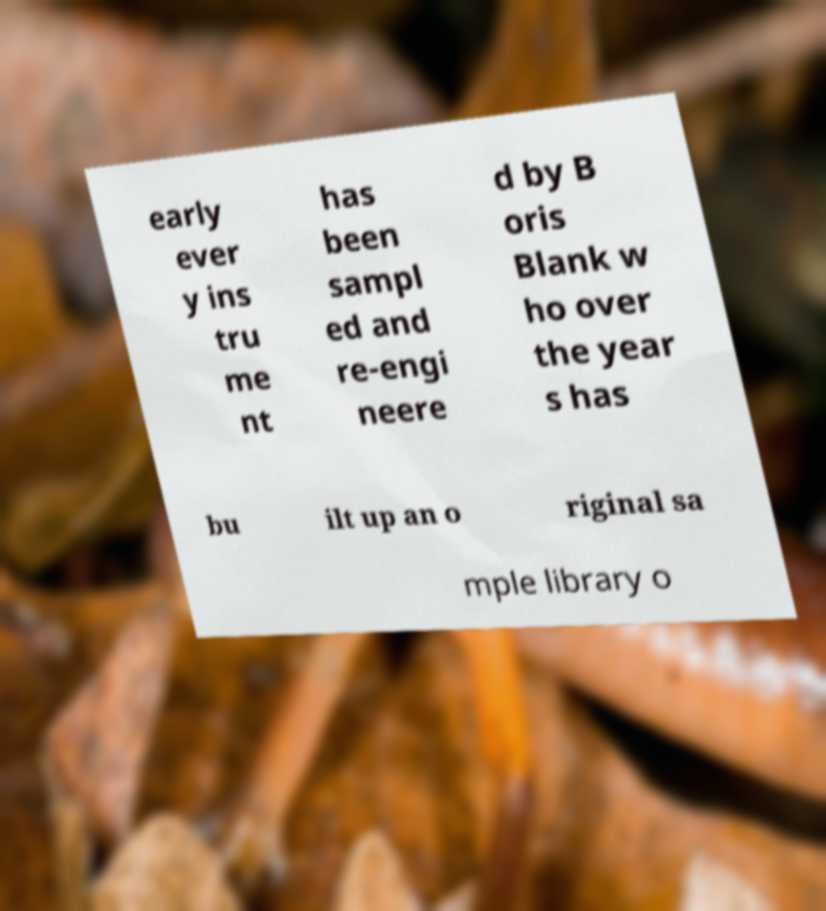Can you accurately transcribe the text from the provided image for me? early ever y ins tru me nt has been sampl ed and re-engi neere d by B oris Blank w ho over the year s has bu ilt up an o riginal sa mple library o 